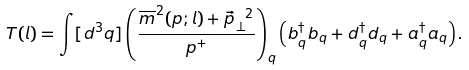<formula> <loc_0><loc_0><loc_500><loc_500>T ( l ) = \int [ d ^ { 3 } q ] \left ( \frac { \overline { m } ^ { 2 } ( p ; l ) + \vec { p } _ { \, \perp } ^ { \ 2 } } { p ^ { + } } \right ) _ { q } \left ( b _ { q } ^ { \dagger } b _ { q } + d _ { q } ^ { \dagger } d _ { q } + a _ { q } ^ { \dagger } a _ { q } \right ) .</formula> 